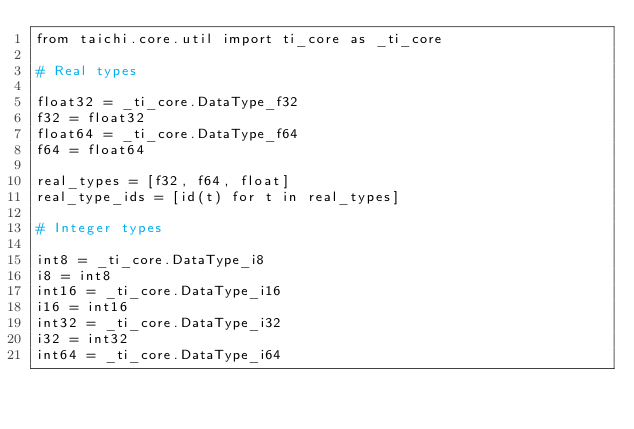Convert code to text. <code><loc_0><loc_0><loc_500><loc_500><_Python_>from taichi.core.util import ti_core as _ti_core

# Real types

float32 = _ti_core.DataType_f32
f32 = float32
float64 = _ti_core.DataType_f64
f64 = float64

real_types = [f32, f64, float]
real_type_ids = [id(t) for t in real_types]

# Integer types

int8 = _ti_core.DataType_i8
i8 = int8
int16 = _ti_core.DataType_i16
i16 = int16
int32 = _ti_core.DataType_i32
i32 = int32
int64 = _ti_core.DataType_i64</code> 